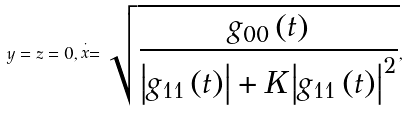<formula> <loc_0><loc_0><loc_500><loc_500>y = z = 0 , \stackrel { \cdot } { x } = \sqrt { \frac { g _ { 0 0 } \left ( t \right ) } { \left | g _ { 1 1 } \left ( t \right ) \right | + K \left | g _ { 1 1 } \left ( t \right ) \right | ^ { 2 } } } ,</formula> 